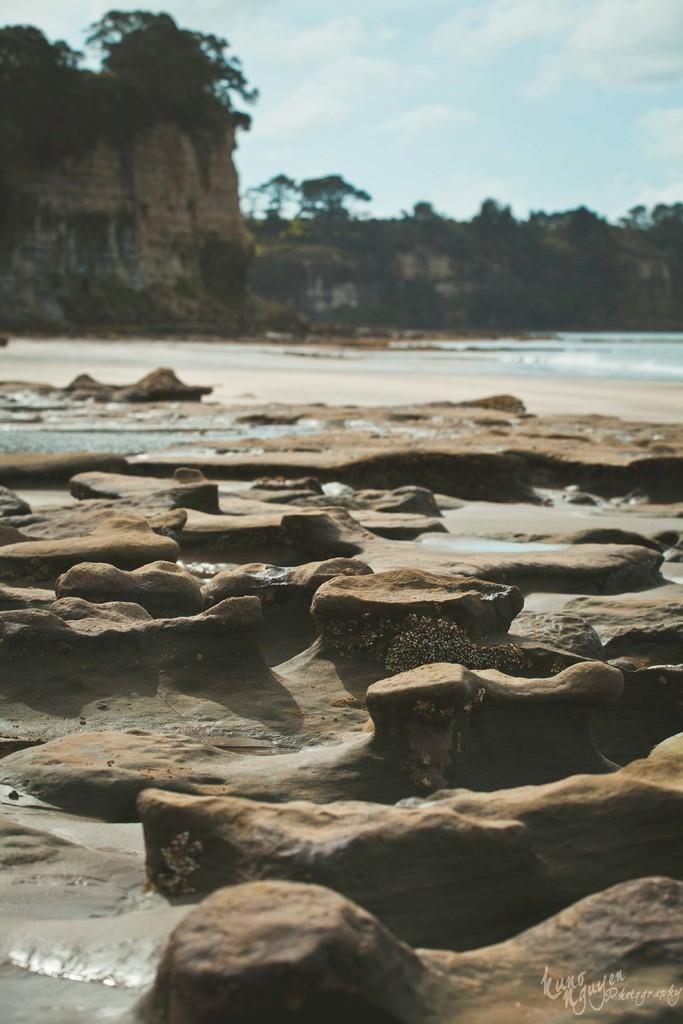What type of natural elements can be seen in the image? There are rocks, water, and trees visible in the image. What is the color and condition of the sky in the image? The sky is blue and cloudy in the image. How many deer can be seen in the image? There are no deer present in the image. What type of knee is visible in the image? There is no knee visible in the image. 